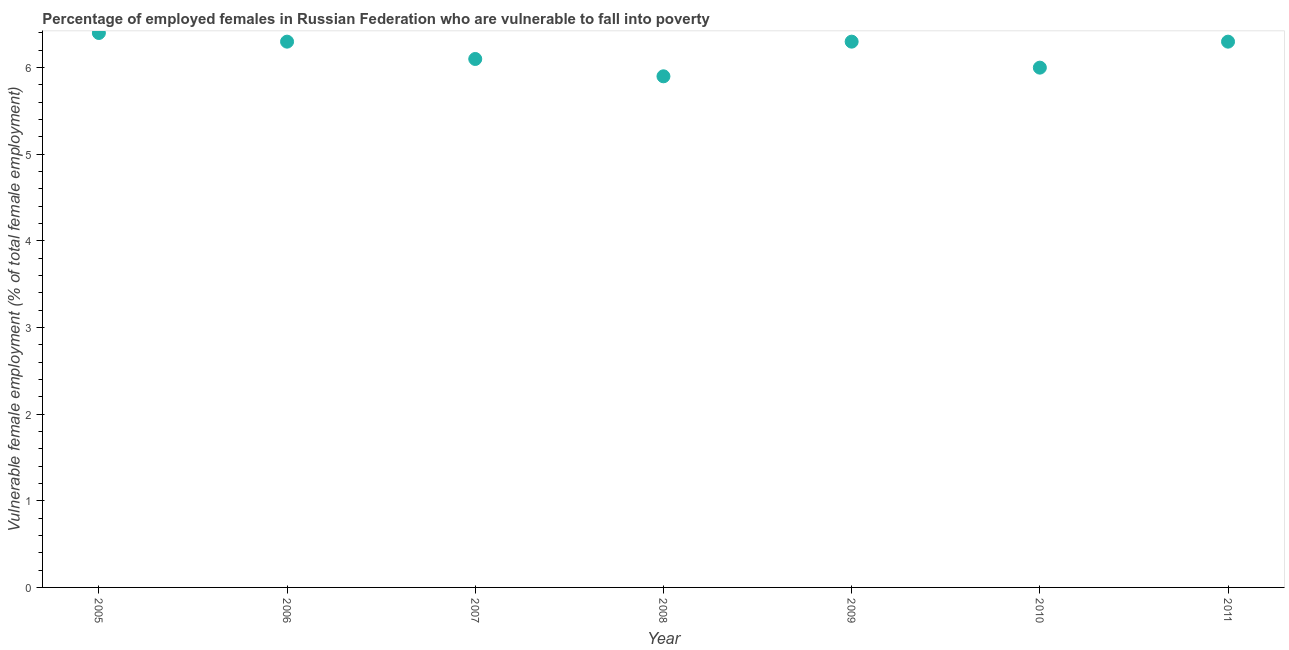What is the percentage of employed females who are vulnerable to fall into poverty in 2008?
Offer a terse response. 5.9. Across all years, what is the maximum percentage of employed females who are vulnerable to fall into poverty?
Your answer should be compact. 6.4. Across all years, what is the minimum percentage of employed females who are vulnerable to fall into poverty?
Offer a very short reply. 5.9. In which year was the percentage of employed females who are vulnerable to fall into poverty maximum?
Offer a terse response. 2005. In which year was the percentage of employed females who are vulnerable to fall into poverty minimum?
Make the answer very short. 2008. What is the sum of the percentage of employed females who are vulnerable to fall into poverty?
Your answer should be compact. 43.3. What is the difference between the percentage of employed females who are vulnerable to fall into poverty in 2008 and 2011?
Provide a short and direct response. -0.4. What is the average percentage of employed females who are vulnerable to fall into poverty per year?
Your answer should be very brief. 6.19. What is the median percentage of employed females who are vulnerable to fall into poverty?
Offer a terse response. 6.3. Do a majority of the years between 2009 and 2006 (inclusive) have percentage of employed females who are vulnerable to fall into poverty greater than 2.2 %?
Your answer should be compact. Yes. What is the ratio of the percentage of employed females who are vulnerable to fall into poverty in 2008 to that in 2011?
Give a very brief answer. 0.94. What is the difference between the highest and the second highest percentage of employed females who are vulnerable to fall into poverty?
Provide a succinct answer. 0.1. What is the difference between the highest and the lowest percentage of employed females who are vulnerable to fall into poverty?
Offer a very short reply. 0.5. In how many years, is the percentage of employed females who are vulnerable to fall into poverty greater than the average percentage of employed females who are vulnerable to fall into poverty taken over all years?
Keep it short and to the point. 4. What is the title of the graph?
Offer a very short reply. Percentage of employed females in Russian Federation who are vulnerable to fall into poverty. What is the label or title of the X-axis?
Keep it short and to the point. Year. What is the label or title of the Y-axis?
Offer a very short reply. Vulnerable female employment (% of total female employment). What is the Vulnerable female employment (% of total female employment) in 2005?
Ensure brevity in your answer.  6.4. What is the Vulnerable female employment (% of total female employment) in 2006?
Provide a succinct answer. 6.3. What is the Vulnerable female employment (% of total female employment) in 2007?
Offer a very short reply. 6.1. What is the Vulnerable female employment (% of total female employment) in 2008?
Provide a short and direct response. 5.9. What is the Vulnerable female employment (% of total female employment) in 2009?
Ensure brevity in your answer.  6.3. What is the Vulnerable female employment (% of total female employment) in 2010?
Your answer should be compact. 6. What is the Vulnerable female employment (% of total female employment) in 2011?
Provide a succinct answer. 6.3. What is the difference between the Vulnerable female employment (% of total female employment) in 2005 and 2006?
Ensure brevity in your answer.  0.1. What is the difference between the Vulnerable female employment (% of total female employment) in 2006 and 2008?
Your response must be concise. 0.4. What is the difference between the Vulnerable female employment (% of total female employment) in 2006 and 2010?
Your response must be concise. 0.3. What is the difference between the Vulnerable female employment (% of total female employment) in 2007 and 2009?
Provide a short and direct response. -0.2. What is the ratio of the Vulnerable female employment (% of total female employment) in 2005 to that in 2007?
Offer a terse response. 1.05. What is the ratio of the Vulnerable female employment (% of total female employment) in 2005 to that in 2008?
Your answer should be compact. 1.08. What is the ratio of the Vulnerable female employment (% of total female employment) in 2005 to that in 2009?
Provide a short and direct response. 1.02. What is the ratio of the Vulnerable female employment (% of total female employment) in 2005 to that in 2010?
Make the answer very short. 1.07. What is the ratio of the Vulnerable female employment (% of total female employment) in 2005 to that in 2011?
Ensure brevity in your answer.  1.02. What is the ratio of the Vulnerable female employment (% of total female employment) in 2006 to that in 2007?
Offer a very short reply. 1.03. What is the ratio of the Vulnerable female employment (% of total female employment) in 2006 to that in 2008?
Your answer should be very brief. 1.07. What is the ratio of the Vulnerable female employment (% of total female employment) in 2006 to that in 2009?
Offer a terse response. 1. What is the ratio of the Vulnerable female employment (% of total female employment) in 2006 to that in 2011?
Make the answer very short. 1. What is the ratio of the Vulnerable female employment (% of total female employment) in 2007 to that in 2008?
Your answer should be compact. 1.03. What is the ratio of the Vulnerable female employment (% of total female employment) in 2007 to that in 2009?
Your answer should be very brief. 0.97. What is the ratio of the Vulnerable female employment (% of total female employment) in 2008 to that in 2009?
Keep it short and to the point. 0.94. What is the ratio of the Vulnerable female employment (% of total female employment) in 2008 to that in 2011?
Give a very brief answer. 0.94. What is the ratio of the Vulnerable female employment (% of total female employment) in 2009 to that in 2010?
Provide a succinct answer. 1.05. What is the ratio of the Vulnerable female employment (% of total female employment) in 2010 to that in 2011?
Your answer should be very brief. 0.95. 